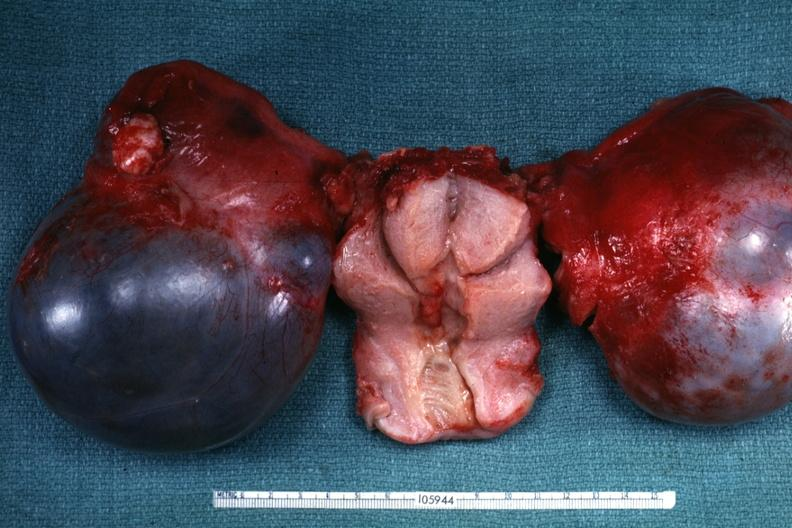what does this image show?
Answer the question using a single word or phrase. External view of bilateral cystic ovarian tumors with uterus slide labeled cystadenocarcinoma malignancy is not obvious from gross appearance 